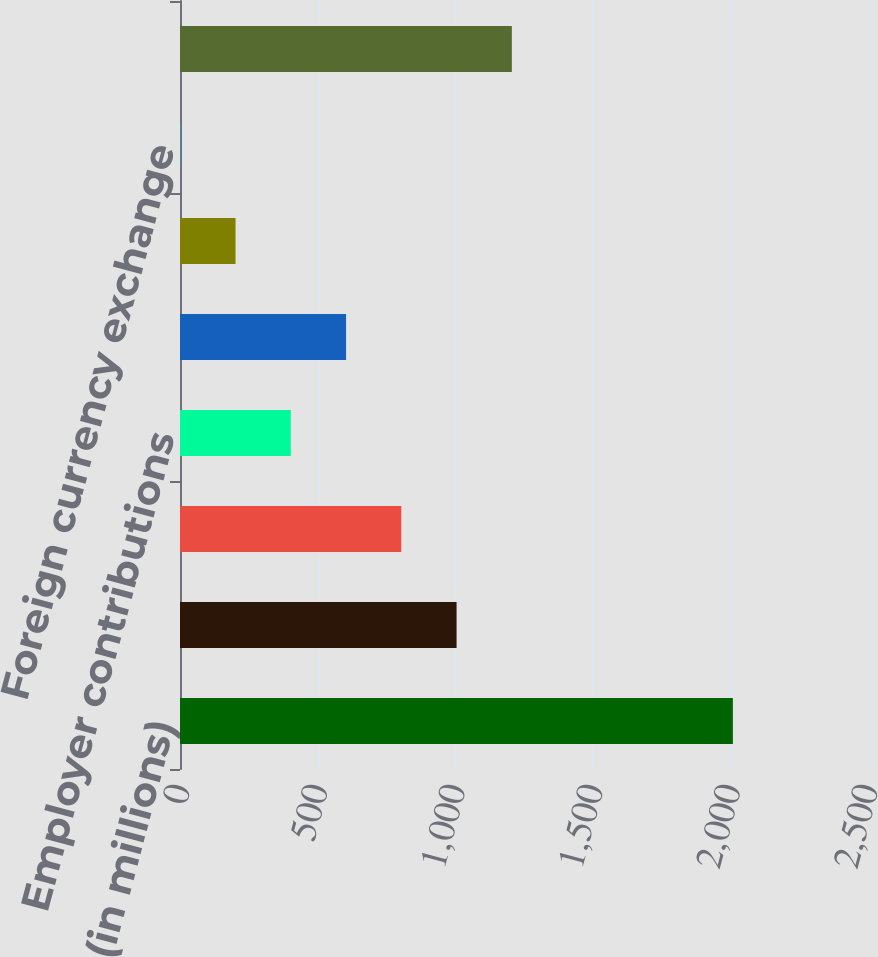Convert chart to OTSL. <chart><loc_0><loc_0><loc_500><loc_500><bar_chart><fcel>(in millions)<fcel>Beginning fair value<fcel>Actual return on plan assets<fcel>Employer contributions<fcel>Benefits paid<fcel>Net transfers in (out)<fcel>Foreign currency exchange<fcel>Ending fair value<nl><fcel>2009<fcel>1005<fcel>804.2<fcel>402.6<fcel>603.4<fcel>201.8<fcel>1<fcel>1205.8<nl></chart> 